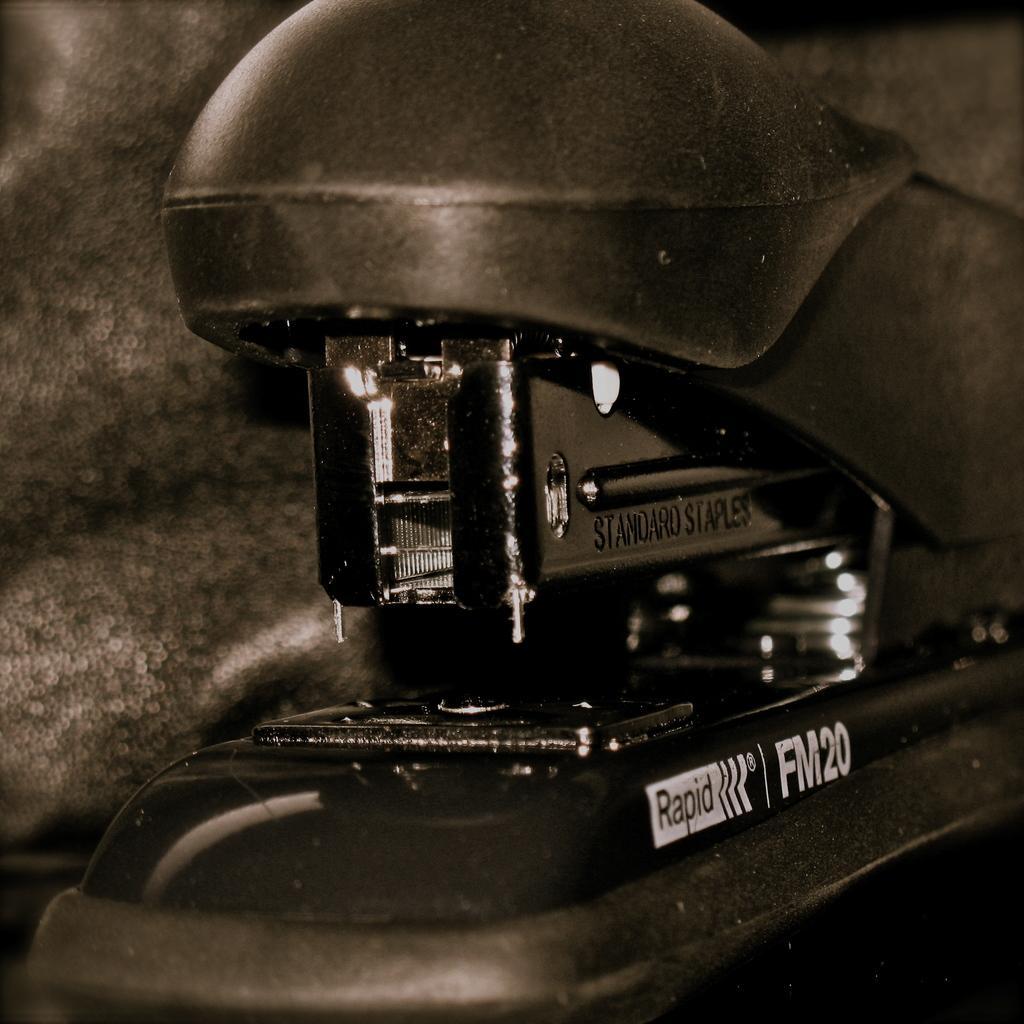Can you describe this image briefly? This is a black and white image. In this image there is a stapler. On that something is written. 